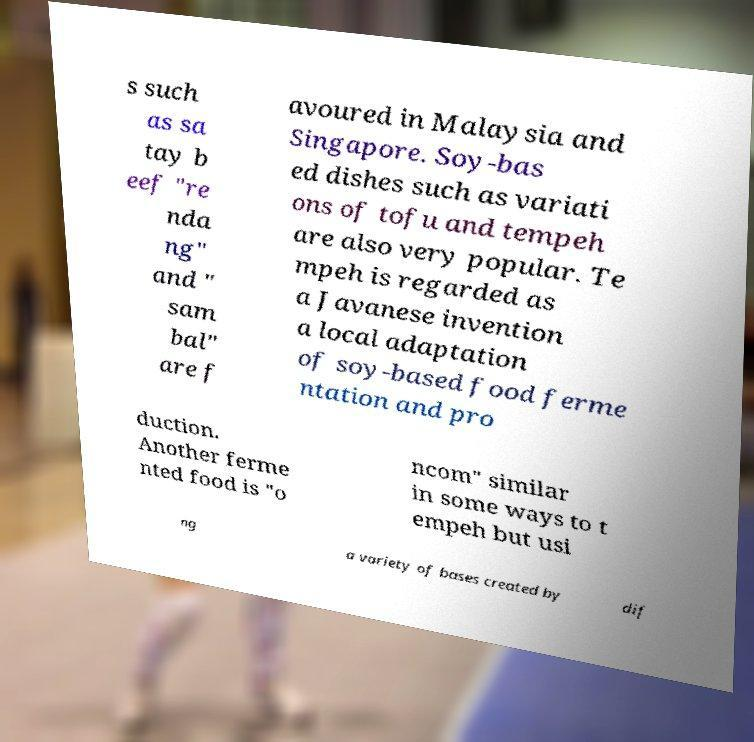Can you accurately transcribe the text from the provided image for me? s such as sa tay b eef "re nda ng" and " sam bal" are f avoured in Malaysia and Singapore. Soy-bas ed dishes such as variati ons of tofu and tempeh are also very popular. Te mpeh is regarded as a Javanese invention a local adaptation of soy-based food ferme ntation and pro duction. Another ferme nted food is "o ncom" similar in some ways to t empeh but usi ng a variety of bases created by dif 